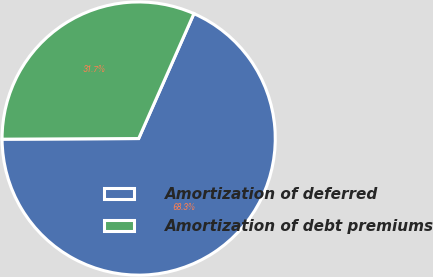Convert chart to OTSL. <chart><loc_0><loc_0><loc_500><loc_500><pie_chart><fcel>Amortization of deferred<fcel>Amortization of debt premiums<nl><fcel>68.3%<fcel>31.7%<nl></chart> 